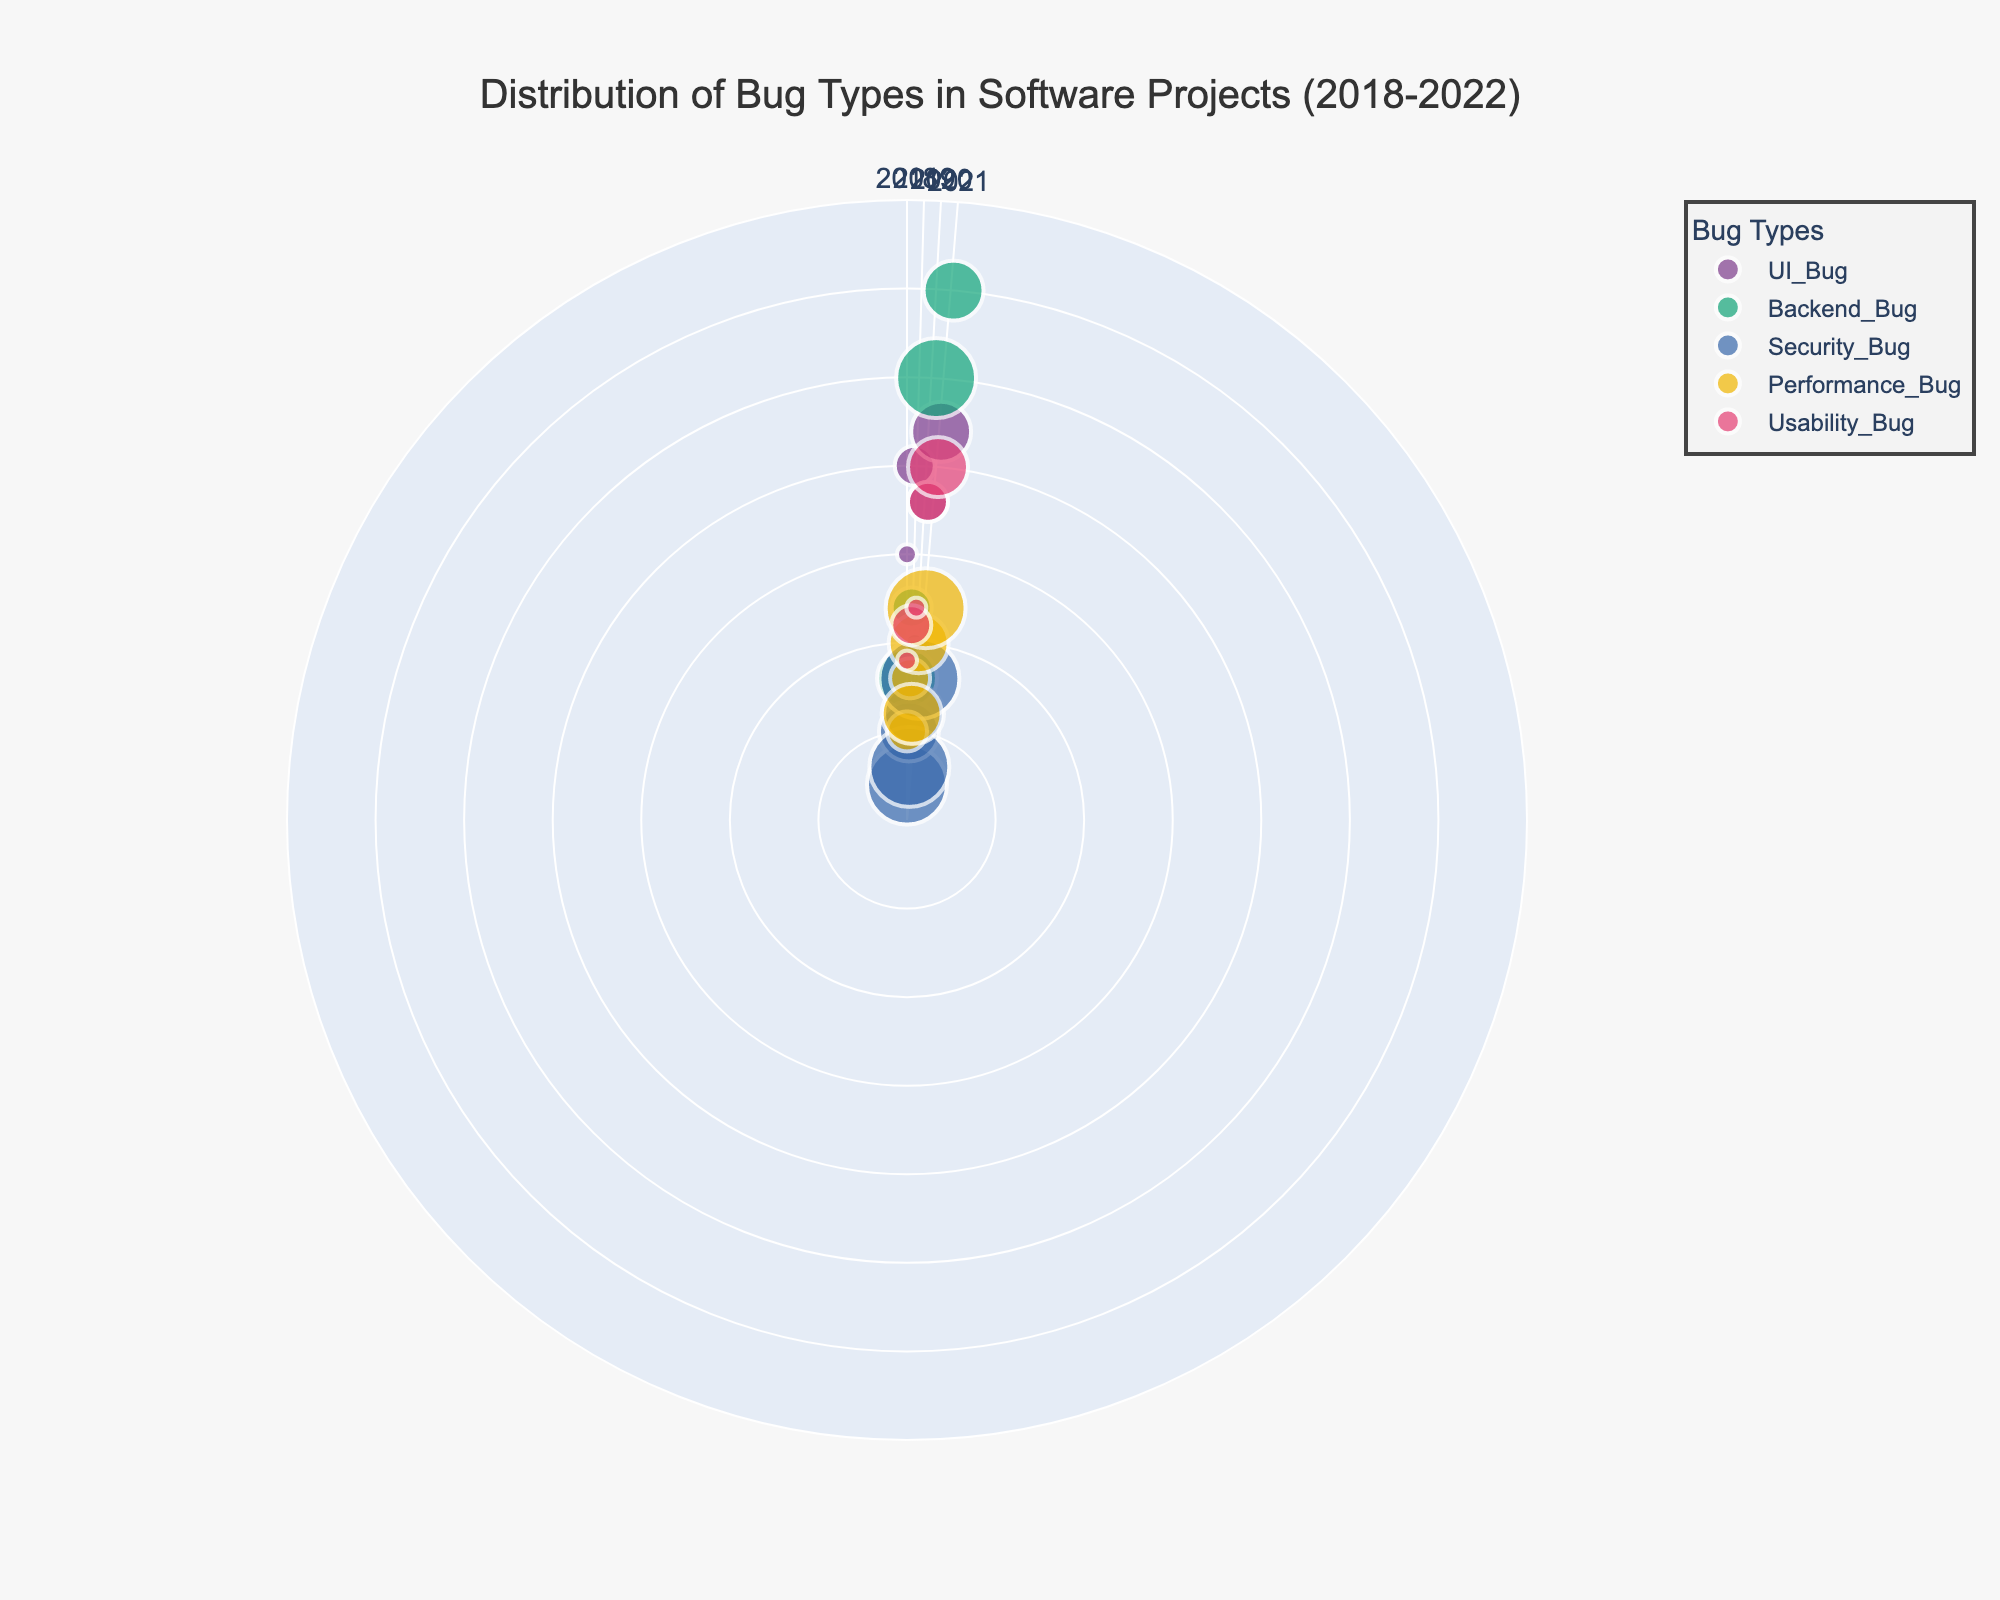What is the title of the figure? The title is displayed prominently at the top of the figure.
Answer: Distribution of Bug Types in Software Projects (2018-2022) How many bug types are represented in the figure? By counting the number of unique colors in the legend, we see distinct colors for each bug type.
Answer: 5 Which year shows the highest frequency of Backend Bugs? By locating Backend Bugs and examining the radial positions (frequency values) for each year, the highest frequency can be identified.
Answer: 2022 Which bug type had the highest severity in 2021? By checking the legend for severity size mapping, and finding the largest marker in 2021 (the angular position), we see that Backend Bugs are critical in 2021.
Answer: Backend Bug What is the range of frequencies displayed on the radial axis? The radial axis range can be read directly from the axis.
Answer: 0 to 35 Compare the frequency of UI Bugs in 2019 to 2020. By finding UI Bugs’ markers in the positions corresponding to 2019 and 2020, and comparing their radial (frequency) values, we see that in 2019 the frequency was 20, and in 2020 it was 10.
Answer: 2019 > 2020 What is the average frequency of Usability Bugs over the given years? Sum the frequencies for Usability Bugs in each year and divide by the number of years: (9 + 11 + 12 + 18 + 20) / 5.
Answer: 14 Which bug type had no critical severity assigned from 2018 to 2022? By checking the sizes allocated (larger sizes mean more severe) for each bug type and identifying any type not having the largest size (critical), UI Bugs and Usability Bugs have no critical severity.
Answer: UI Bug, Usability Bug How does the frequency of Security Bugs in 2020 compare to Performance Bugs in 2020? By comparing the radial positions at the 2020 angular positions for Security Bugs and Performance Bugs, we see that Security Bugs have a frequency of 3 and Performance Bugs have a frequency of 6.
Answer: Security Bugs < Performance Bugs Which bug type exhibited the most consistent frequency over the years? By observing which bug type's markers have the smallest variability in radial distance across different years, Security Bugs show roughly consistent counts.
Answer: Security Bug 